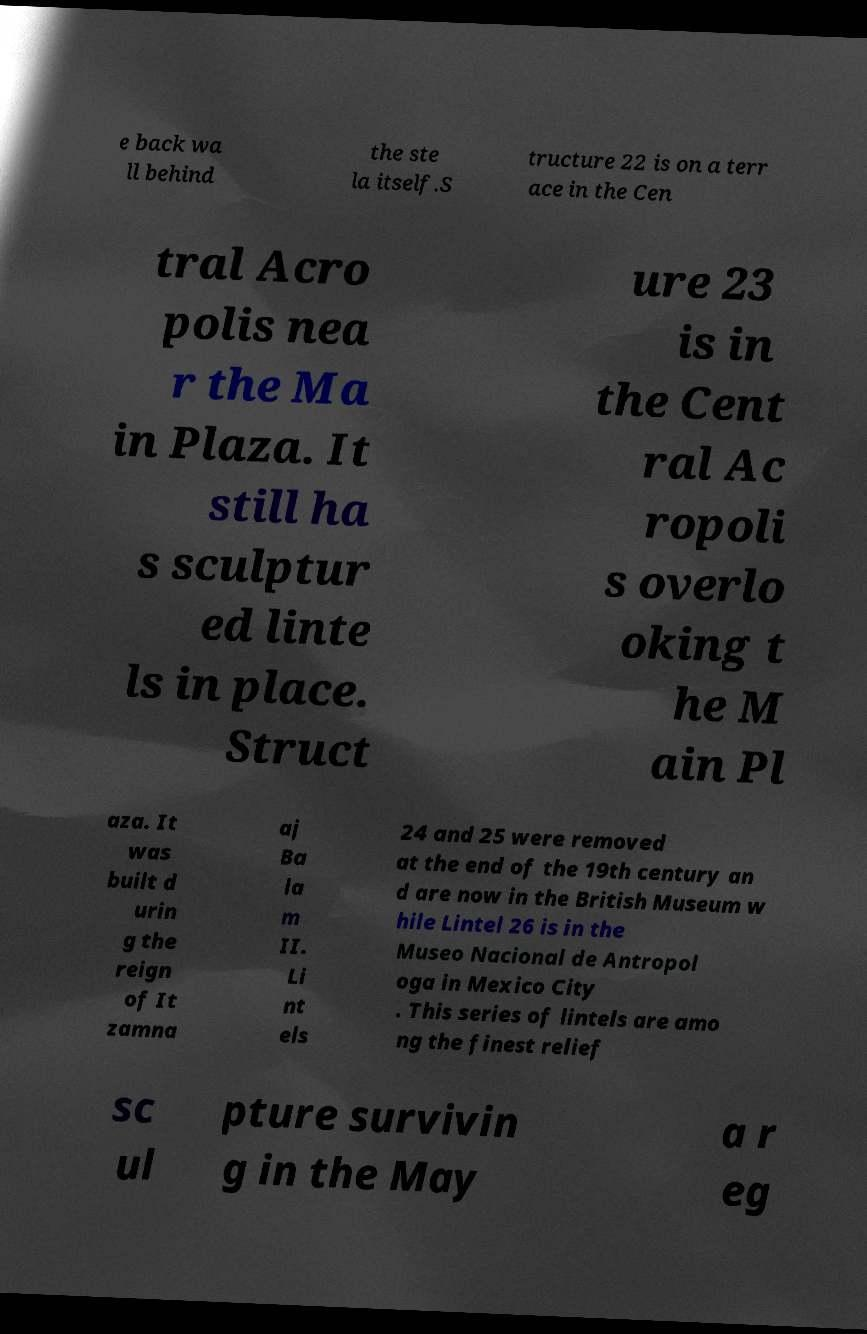Could you assist in decoding the text presented in this image and type it out clearly? e back wa ll behind the ste la itself.S tructure 22 is on a terr ace in the Cen tral Acro polis nea r the Ma in Plaza. It still ha s sculptur ed linte ls in place. Struct ure 23 is in the Cent ral Ac ropoli s overlo oking t he M ain Pl aza. It was built d urin g the reign of It zamna aj Ba la m II. Li nt els 24 and 25 were removed at the end of the 19th century an d are now in the British Museum w hile Lintel 26 is in the Museo Nacional de Antropol oga in Mexico City . This series of lintels are amo ng the finest relief sc ul pture survivin g in the May a r eg 